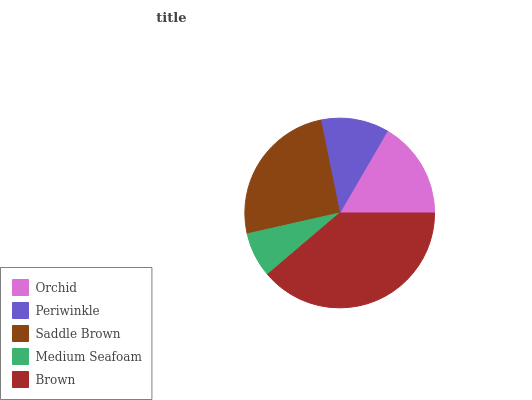Is Medium Seafoam the minimum?
Answer yes or no. Yes. Is Brown the maximum?
Answer yes or no. Yes. Is Periwinkle the minimum?
Answer yes or no. No. Is Periwinkle the maximum?
Answer yes or no. No. Is Orchid greater than Periwinkle?
Answer yes or no. Yes. Is Periwinkle less than Orchid?
Answer yes or no. Yes. Is Periwinkle greater than Orchid?
Answer yes or no. No. Is Orchid less than Periwinkle?
Answer yes or no. No. Is Orchid the high median?
Answer yes or no. Yes. Is Orchid the low median?
Answer yes or no. Yes. Is Saddle Brown the high median?
Answer yes or no. No. Is Medium Seafoam the low median?
Answer yes or no. No. 